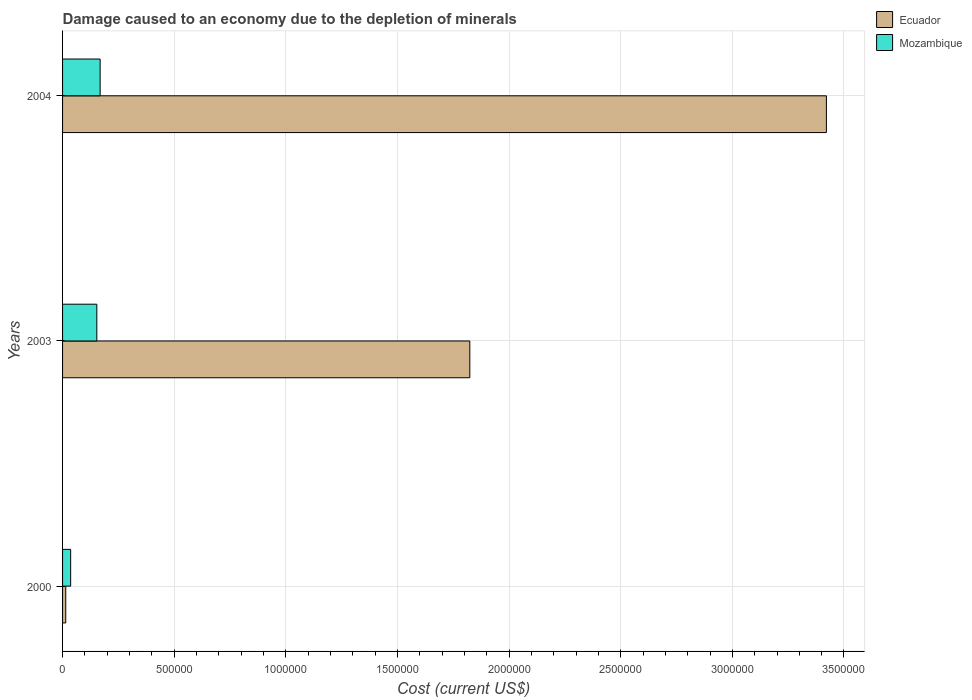How many groups of bars are there?
Keep it short and to the point. 3. Are the number of bars per tick equal to the number of legend labels?
Your answer should be very brief. Yes. Are the number of bars on each tick of the Y-axis equal?
Offer a very short reply. Yes. How many bars are there on the 2nd tick from the top?
Your response must be concise. 2. What is the label of the 2nd group of bars from the top?
Offer a very short reply. 2003. What is the cost of damage caused due to the depletion of minerals in Mozambique in 2000?
Give a very brief answer. 3.62e+04. Across all years, what is the maximum cost of damage caused due to the depletion of minerals in Mozambique?
Your response must be concise. 1.68e+05. Across all years, what is the minimum cost of damage caused due to the depletion of minerals in Mozambique?
Your response must be concise. 3.62e+04. In which year was the cost of damage caused due to the depletion of minerals in Ecuador maximum?
Offer a terse response. 2004. In which year was the cost of damage caused due to the depletion of minerals in Ecuador minimum?
Your answer should be compact. 2000. What is the total cost of damage caused due to the depletion of minerals in Ecuador in the graph?
Provide a short and direct response. 5.26e+06. What is the difference between the cost of damage caused due to the depletion of minerals in Mozambique in 2003 and that in 2004?
Your response must be concise. -1.48e+04. What is the difference between the cost of damage caused due to the depletion of minerals in Mozambique in 2004 and the cost of damage caused due to the depletion of minerals in Ecuador in 2000?
Your answer should be compact. 1.54e+05. What is the average cost of damage caused due to the depletion of minerals in Mozambique per year?
Your response must be concise. 1.19e+05. In the year 2000, what is the difference between the cost of damage caused due to the depletion of minerals in Ecuador and cost of damage caused due to the depletion of minerals in Mozambique?
Give a very brief answer. -2.20e+04. In how many years, is the cost of damage caused due to the depletion of minerals in Ecuador greater than 2200000 US$?
Offer a very short reply. 1. What is the ratio of the cost of damage caused due to the depletion of minerals in Mozambique in 2000 to that in 2003?
Offer a terse response. 0.24. What is the difference between the highest and the second highest cost of damage caused due to the depletion of minerals in Ecuador?
Provide a short and direct response. 1.60e+06. What is the difference between the highest and the lowest cost of damage caused due to the depletion of minerals in Ecuador?
Keep it short and to the point. 3.41e+06. In how many years, is the cost of damage caused due to the depletion of minerals in Mozambique greater than the average cost of damage caused due to the depletion of minerals in Mozambique taken over all years?
Provide a succinct answer. 2. What does the 1st bar from the top in 2000 represents?
Your answer should be compact. Mozambique. What does the 1st bar from the bottom in 2003 represents?
Your answer should be compact. Ecuador. How many bars are there?
Your answer should be compact. 6. What is the difference between two consecutive major ticks on the X-axis?
Offer a very short reply. 5.00e+05. Are the values on the major ticks of X-axis written in scientific E-notation?
Provide a succinct answer. No. Does the graph contain any zero values?
Keep it short and to the point. No. How many legend labels are there?
Provide a succinct answer. 2. What is the title of the graph?
Make the answer very short. Damage caused to an economy due to the depletion of minerals. What is the label or title of the X-axis?
Make the answer very short. Cost (current US$). What is the Cost (current US$) in Ecuador in 2000?
Make the answer very short. 1.42e+04. What is the Cost (current US$) of Mozambique in 2000?
Your response must be concise. 3.62e+04. What is the Cost (current US$) of Ecuador in 2003?
Keep it short and to the point. 1.82e+06. What is the Cost (current US$) of Mozambique in 2003?
Your answer should be very brief. 1.53e+05. What is the Cost (current US$) of Ecuador in 2004?
Your answer should be compact. 3.42e+06. What is the Cost (current US$) of Mozambique in 2004?
Your response must be concise. 1.68e+05. Across all years, what is the maximum Cost (current US$) of Ecuador?
Offer a very short reply. 3.42e+06. Across all years, what is the maximum Cost (current US$) of Mozambique?
Your answer should be compact. 1.68e+05. Across all years, what is the minimum Cost (current US$) of Ecuador?
Give a very brief answer. 1.42e+04. Across all years, what is the minimum Cost (current US$) of Mozambique?
Offer a terse response. 3.62e+04. What is the total Cost (current US$) of Ecuador in the graph?
Provide a short and direct response. 5.26e+06. What is the total Cost (current US$) in Mozambique in the graph?
Your response must be concise. 3.58e+05. What is the difference between the Cost (current US$) in Ecuador in 2000 and that in 2003?
Offer a terse response. -1.81e+06. What is the difference between the Cost (current US$) of Mozambique in 2000 and that in 2003?
Make the answer very short. -1.17e+05. What is the difference between the Cost (current US$) in Ecuador in 2000 and that in 2004?
Offer a terse response. -3.41e+06. What is the difference between the Cost (current US$) in Mozambique in 2000 and that in 2004?
Offer a very short reply. -1.32e+05. What is the difference between the Cost (current US$) of Ecuador in 2003 and that in 2004?
Your response must be concise. -1.60e+06. What is the difference between the Cost (current US$) in Mozambique in 2003 and that in 2004?
Your answer should be compact. -1.48e+04. What is the difference between the Cost (current US$) of Ecuador in 2000 and the Cost (current US$) of Mozambique in 2003?
Offer a terse response. -1.39e+05. What is the difference between the Cost (current US$) in Ecuador in 2000 and the Cost (current US$) in Mozambique in 2004?
Ensure brevity in your answer.  -1.54e+05. What is the difference between the Cost (current US$) in Ecuador in 2003 and the Cost (current US$) in Mozambique in 2004?
Your answer should be very brief. 1.66e+06. What is the average Cost (current US$) of Ecuador per year?
Keep it short and to the point. 1.75e+06. What is the average Cost (current US$) in Mozambique per year?
Offer a very short reply. 1.19e+05. In the year 2000, what is the difference between the Cost (current US$) of Ecuador and Cost (current US$) of Mozambique?
Your answer should be compact. -2.20e+04. In the year 2003, what is the difference between the Cost (current US$) in Ecuador and Cost (current US$) in Mozambique?
Ensure brevity in your answer.  1.67e+06. In the year 2004, what is the difference between the Cost (current US$) of Ecuador and Cost (current US$) of Mozambique?
Provide a succinct answer. 3.25e+06. What is the ratio of the Cost (current US$) of Ecuador in 2000 to that in 2003?
Your answer should be compact. 0.01. What is the ratio of the Cost (current US$) of Mozambique in 2000 to that in 2003?
Provide a succinct answer. 0.24. What is the ratio of the Cost (current US$) in Ecuador in 2000 to that in 2004?
Provide a succinct answer. 0. What is the ratio of the Cost (current US$) of Mozambique in 2000 to that in 2004?
Provide a short and direct response. 0.22. What is the ratio of the Cost (current US$) in Ecuador in 2003 to that in 2004?
Make the answer very short. 0.53. What is the ratio of the Cost (current US$) of Mozambique in 2003 to that in 2004?
Provide a short and direct response. 0.91. What is the difference between the highest and the second highest Cost (current US$) in Ecuador?
Offer a terse response. 1.60e+06. What is the difference between the highest and the second highest Cost (current US$) of Mozambique?
Ensure brevity in your answer.  1.48e+04. What is the difference between the highest and the lowest Cost (current US$) in Ecuador?
Offer a very short reply. 3.41e+06. What is the difference between the highest and the lowest Cost (current US$) in Mozambique?
Offer a very short reply. 1.32e+05. 